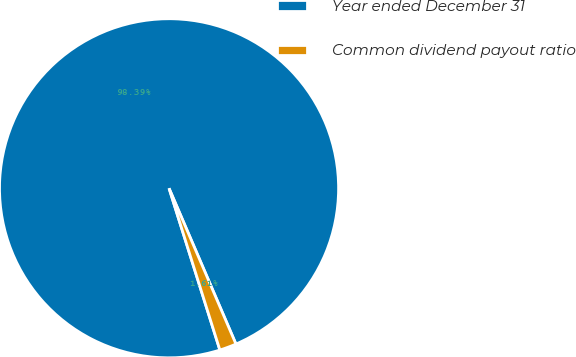<chart> <loc_0><loc_0><loc_500><loc_500><pie_chart><fcel>Year ended December 31<fcel>Common dividend payout ratio<nl><fcel>98.39%<fcel>1.61%<nl></chart> 